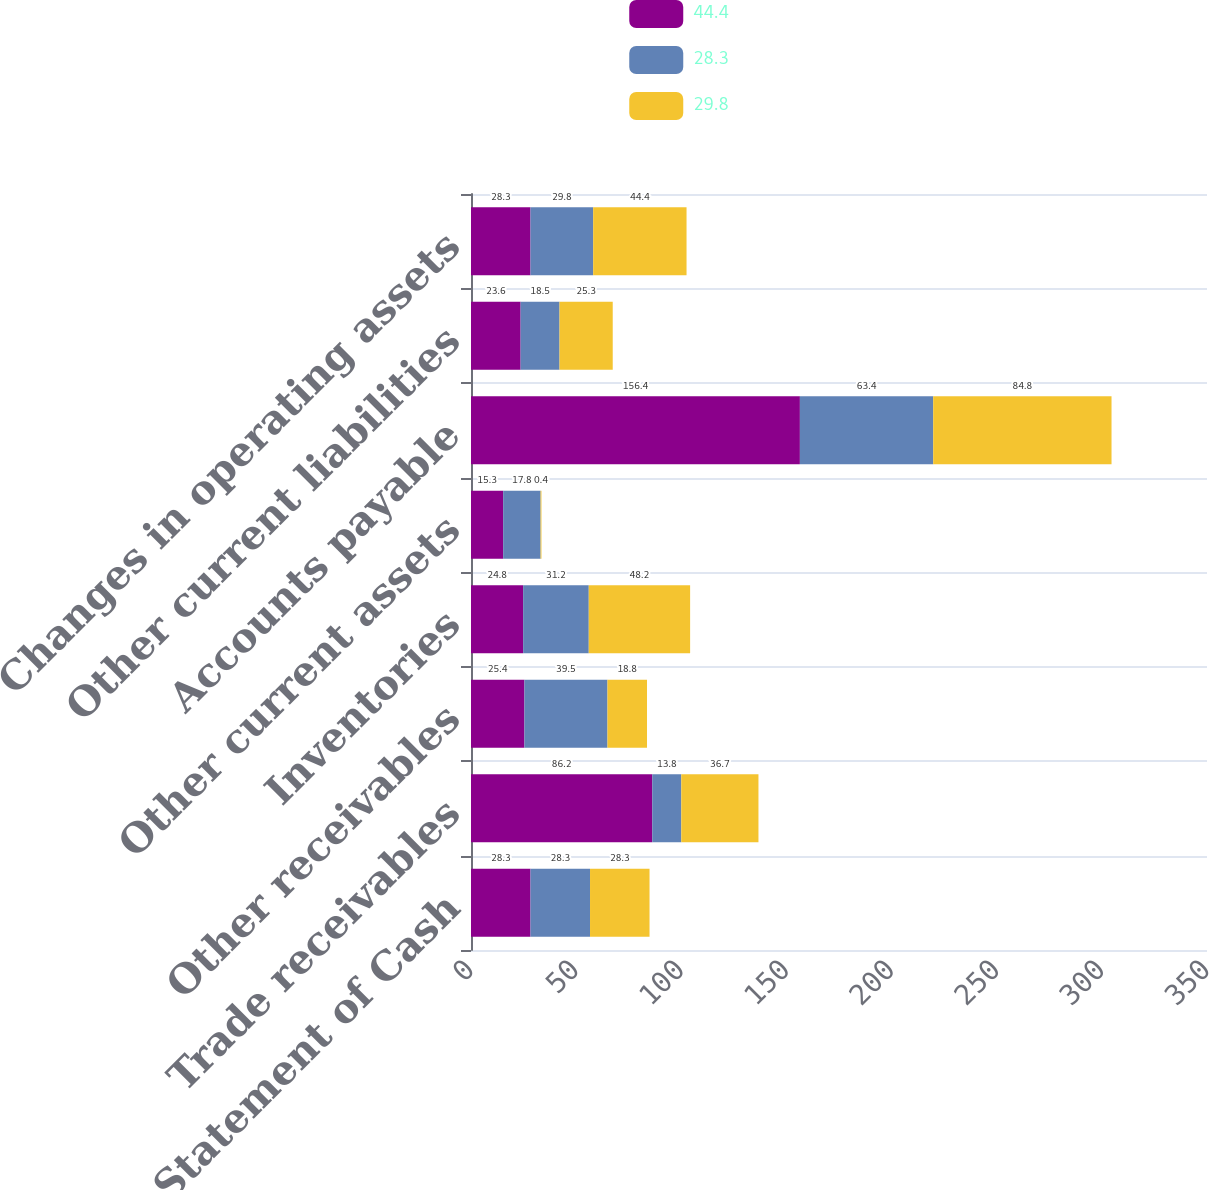Convert chart to OTSL. <chart><loc_0><loc_0><loc_500><loc_500><stacked_bar_chart><ecel><fcel>Consolidated Statement of Cash<fcel>Trade receivables<fcel>Other receivables<fcel>Inventories<fcel>Other current assets<fcel>Accounts payable<fcel>Other current liabilities<fcel>Changes in operating assets<nl><fcel>44.4<fcel>28.3<fcel>86.2<fcel>25.4<fcel>24.8<fcel>15.3<fcel>156.4<fcel>23.6<fcel>28.3<nl><fcel>28.3<fcel>28.3<fcel>13.8<fcel>39.5<fcel>31.2<fcel>17.8<fcel>63.4<fcel>18.5<fcel>29.8<nl><fcel>29.8<fcel>28.3<fcel>36.7<fcel>18.8<fcel>48.2<fcel>0.4<fcel>84.8<fcel>25.3<fcel>44.4<nl></chart> 